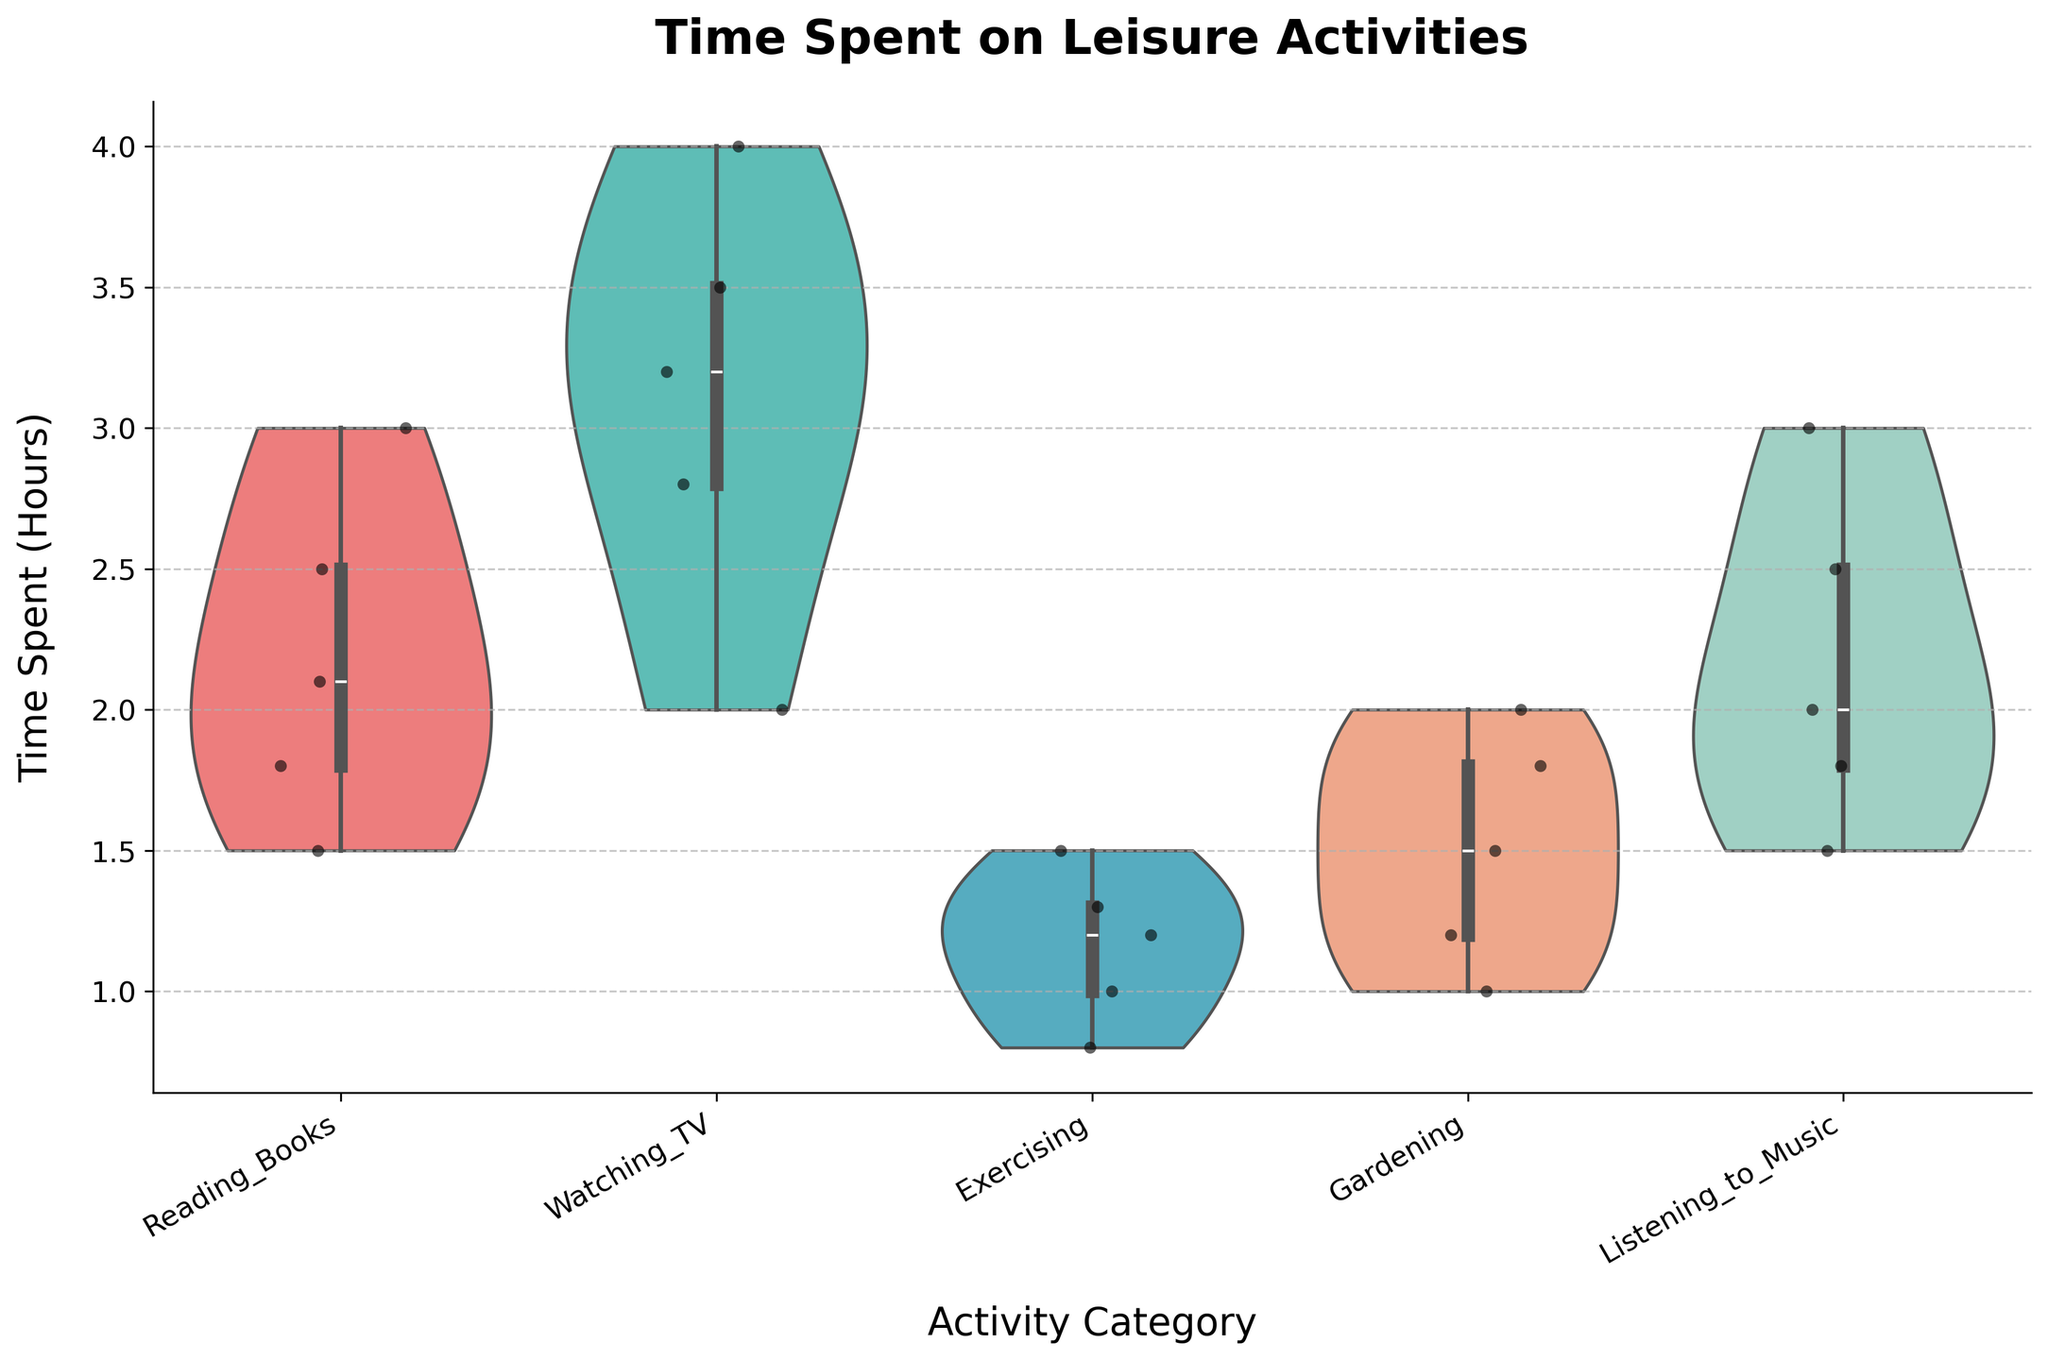What is the title of the plot? The title of the plot is located at the top and typically provides an overview of what the data visualizes. In this figure, the title states the subject being analyzed.
Answer: Time Spent on Leisure Activities Which color corresponds to the 'Exercising' category? The color corresponding to each category is determined by the custom color palette defined in the creation of the plot. The 'Exercising' category is visually represented by a distinct color.
Answer: Light blue (#45B7D1) How many different categories of leisure activities are shown in the plot? The x-axis of the plot displays labels for each leisure activity being compared, indicating how many distinct categories are present.
Answer: 5 What is the range of time spent on 'Watching TV'? The range can be determined by examining the extent of the violin plot along the y-axis for the 'Watching TV' category. The range is from the lowest to the highest points.
Answer: 2.0 to 4.0 hours Which leisure activity has the widest distribution of time spent? To determine the widest distribution, observe the spread of each violin plot along the y-axis. The category with the largest vertical stretch represents the widest distribution.
Answer: Watching TV What is the median time spent on 'Reading Books'? The median can be observed from the central point of the box embedded within the violin plot for the 'Reading Books' category.
Answer: 2.1 hours Which leisure activity has the most similar time spent distribution to 'Exercising'? By comparing the shape and spread of each violin plot, the violin plot that most closely matches the distribution of 'Exercising' can be identified.
Answer: Gardening What is the maximum time spent on 'Listening to Music'? The maximum value can be observed at the uppermost point of the violin plot for the 'Listening to Music' category.
Answer: 3.0 hours Which category shows a bimodal distribution in the time spent? A bimodal distribution will have two peaks or modes within the violin plot. By examining each category, the one with this characteristic distribution can be identified.
Answer: Gardening Are there any outliers in the 'Gardening' category? Outliers would be represented as points that fall outside the general spread of the violin plot. By examining 'Gardening', we identify if such points exist.
Answer: No 